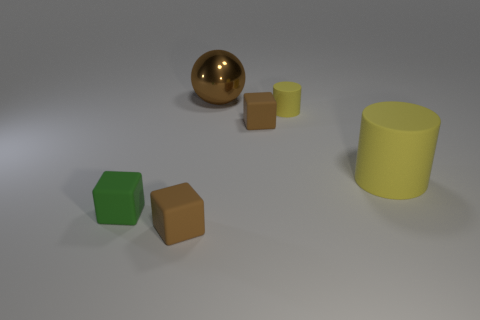What shapes are present in the image? The image includes a sphere, two cylinders of different sizes, and two cubes. 